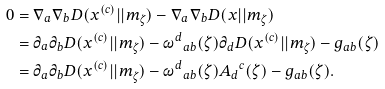<formula> <loc_0><loc_0><loc_500><loc_500>0 & = \nabla _ { a } \nabla _ { b } D ( x ^ { ( c ) } | | m _ { \zeta } ) - \nabla _ { a } \nabla _ { b } D ( x | | m _ { \zeta } ) \\ & = \partial _ { a } \partial _ { b } D ( x ^ { ( c ) } | | m _ { \zeta } ) - { \omega ^ { d } } _ { a b } ( \zeta ) \partial _ { d } D ( x ^ { ( c ) } | | m _ { \zeta } ) - g _ { a b } ( \zeta ) \\ & = \partial _ { a } \partial _ { b } D ( x ^ { ( c ) } | | m _ { \zeta } ) - { \omega ^ { d } } _ { a b } ( \zeta ) { A _ { d } } ^ { c } ( \zeta ) - g _ { a b } ( \zeta ) .</formula> 